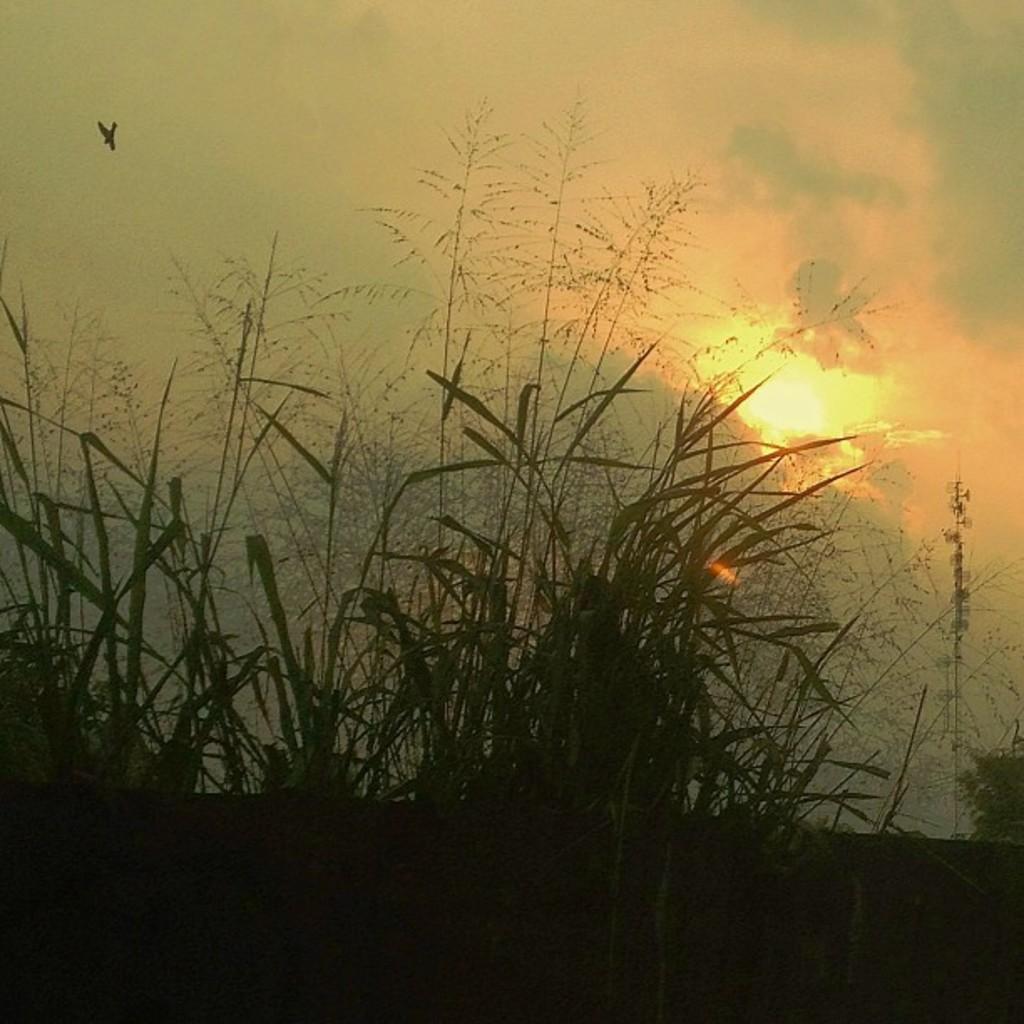Could you give a brief overview of what you see in this image? In the foreground of the picture I can see the green grass. I can see the sunshine and the clouds in the sky. 